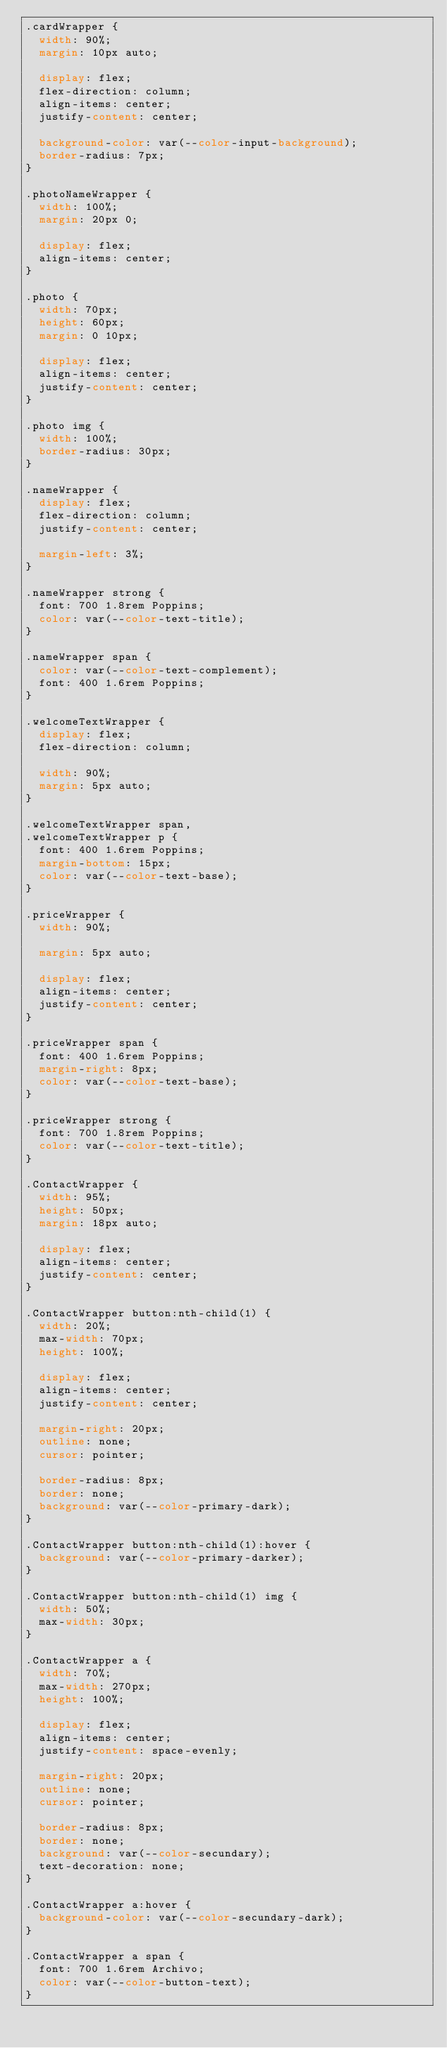Convert code to text. <code><loc_0><loc_0><loc_500><loc_500><_CSS_>.cardWrapper {
  width: 90%;
  margin: 10px auto;

  display: flex;
  flex-direction: column;
  align-items: center;
  justify-content: center;

  background-color: var(--color-input-background);
  border-radius: 7px;
}

.photoNameWrapper {
  width: 100%;
  margin: 20px 0;

  display: flex;
  align-items: center;
}

.photo {
  width: 70px;
  height: 60px;
  margin: 0 10px;

  display: flex;
  align-items: center;
  justify-content: center;
}

.photo img {
  width: 100%;
  border-radius: 30px;
}

.nameWrapper {
  display: flex;
  flex-direction: column;
  justify-content: center;

  margin-left: 3%;
}

.nameWrapper strong {
  font: 700 1.8rem Poppins;
  color: var(--color-text-title);
}

.nameWrapper span {
  color: var(--color-text-complement);
  font: 400 1.6rem Poppins;
}

.welcomeTextWrapper {
  display: flex;
  flex-direction: column;

  width: 90%;
  margin: 5px auto;
}

.welcomeTextWrapper span,
.welcomeTextWrapper p {
  font: 400 1.6rem Poppins;
  margin-bottom: 15px;
  color: var(--color-text-base);
}

.priceWrapper {
  width: 90%;

  margin: 5px auto;

  display: flex;
  align-items: center;
  justify-content: center;
}

.priceWrapper span {
  font: 400 1.6rem Poppins;
  margin-right: 8px;
  color: var(--color-text-base);
}

.priceWrapper strong {
  font: 700 1.8rem Poppins;
  color: var(--color-text-title);
}

.ContactWrapper {
  width: 95%;
  height: 50px;
  margin: 18px auto;

  display: flex;
  align-items: center;
  justify-content: center;
}

.ContactWrapper button:nth-child(1) {
  width: 20%;
  max-width: 70px;
  height: 100%;

  display: flex;
  align-items: center;
  justify-content: center;

  margin-right: 20px;
  outline: none;
  cursor: pointer;

  border-radius: 8px;
  border: none;
  background: var(--color-primary-dark);
}

.ContactWrapper button:nth-child(1):hover {
  background: var(--color-primary-darker);
}

.ContactWrapper button:nth-child(1) img {
  width: 50%;
  max-width: 30px;
}

.ContactWrapper a {
  width: 70%;
  max-width: 270px;
  height: 100%;

  display: flex;
  align-items: center;
  justify-content: space-evenly;

  margin-right: 20px;
  outline: none;
  cursor: pointer;

  border-radius: 8px;
  border: none;
  background: var(--color-secundary);
  text-decoration: none;
}

.ContactWrapper a:hover {
  background-color: var(--color-secundary-dark);
}

.ContactWrapper a span {
  font: 700 1.6rem Archivo;
  color: var(--color-button-text);
}
</code> 